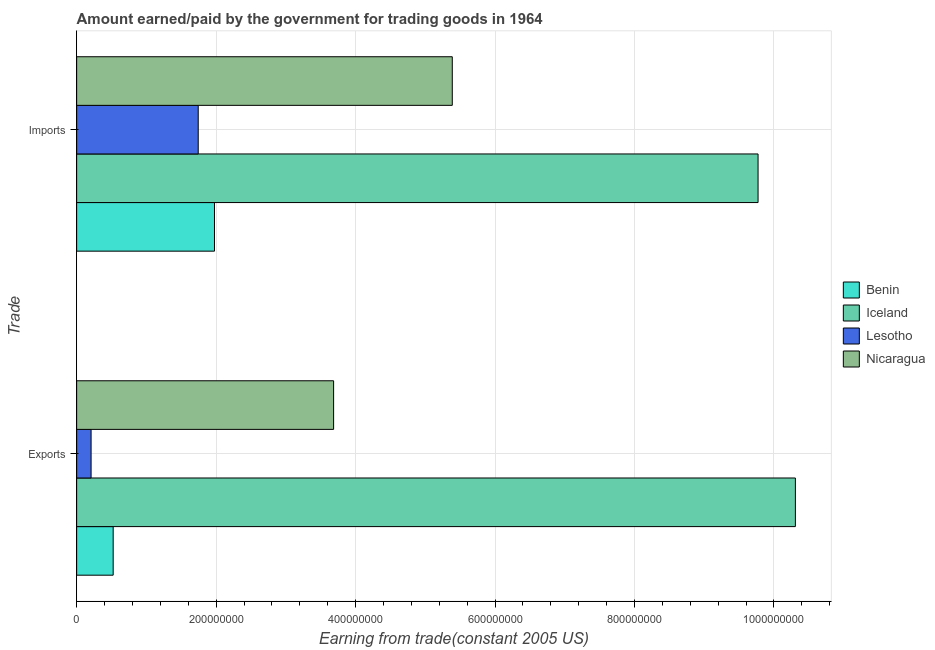How many different coloured bars are there?
Your answer should be very brief. 4. Are the number of bars on each tick of the Y-axis equal?
Give a very brief answer. Yes. How many bars are there on the 2nd tick from the top?
Your answer should be very brief. 4. How many bars are there on the 2nd tick from the bottom?
Ensure brevity in your answer.  4. What is the label of the 2nd group of bars from the top?
Provide a short and direct response. Exports. What is the amount paid for imports in Lesotho?
Offer a terse response. 1.74e+08. Across all countries, what is the maximum amount earned from exports?
Provide a short and direct response. 1.03e+09. Across all countries, what is the minimum amount earned from exports?
Offer a very short reply. 2.07e+07. In which country was the amount earned from exports maximum?
Ensure brevity in your answer.  Iceland. In which country was the amount paid for imports minimum?
Your answer should be compact. Lesotho. What is the total amount earned from exports in the graph?
Your answer should be compact. 1.47e+09. What is the difference between the amount earned from exports in Benin and that in Lesotho?
Make the answer very short. 3.17e+07. What is the difference between the amount paid for imports in Lesotho and the amount earned from exports in Iceland?
Provide a succinct answer. -8.56e+08. What is the average amount paid for imports per country?
Keep it short and to the point. 4.72e+08. What is the difference between the amount paid for imports and amount earned from exports in Iceland?
Offer a very short reply. -5.35e+07. What is the ratio of the amount paid for imports in Iceland to that in Lesotho?
Keep it short and to the point. 5.61. What does the 2nd bar from the top in Imports represents?
Make the answer very short. Lesotho. What does the 3rd bar from the bottom in Imports represents?
Offer a terse response. Lesotho. Are all the bars in the graph horizontal?
Keep it short and to the point. Yes. What is the difference between two consecutive major ticks on the X-axis?
Your response must be concise. 2.00e+08. Does the graph contain any zero values?
Make the answer very short. No. Does the graph contain grids?
Your answer should be very brief. Yes. How are the legend labels stacked?
Your answer should be very brief. Vertical. What is the title of the graph?
Keep it short and to the point. Amount earned/paid by the government for trading goods in 1964. Does "Tuvalu" appear as one of the legend labels in the graph?
Your response must be concise. No. What is the label or title of the X-axis?
Give a very brief answer. Earning from trade(constant 2005 US). What is the label or title of the Y-axis?
Provide a short and direct response. Trade. What is the Earning from trade(constant 2005 US) in Benin in Exports?
Make the answer very short. 5.24e+07. What is the Earning from trade(constant 2005 US) of Iceland in Exports?
Your answer should be very brief. 1.03e+09. What is the Earning from trade(constant 2005 US) of Lesotho in Exports?
Your response must be concise. 2.07e+07. What is the Earning from trade(constant 2005 US) of Nicaragua in Exports?
Offer a very short reply. 3.68e+08. What is the Earning from trade(constant 2005 US) of Benin in Imports?
Keep it short and to the point. 1.98e+08. What is the Earning from trade(constant 2005 US) in Iceland in Imports?
Offer a terse response. 9.77e+08. What is the Earning from trade(constant 2005 US) of Lesotho in Imports?
Your response must be concise. 1.74e+08. What is the Earning from trade(constant 2005 US) of Nicaragua in Imports?
Provide a succinct answer. 5.39e+08. Across all Trade, what is the maximum Earning from trade(constant 2005 US) in Benin?
Your response must be concise. 1.98e+08. Across all Trade, what is the maximum Earning from trade(constant 2005 US) in Iceland?
Provide a short and direct response. 1.03e+09. Across all Trade, what is the maximum Earning from trade(constant 2005 US) of Lesotho?
Your answer should be very brief. 1.74e+08. Across all Trade, what is the maximum Earning from trade(constant 2005 US) in Nicaragua?
Make the answer very short. 5.39e+08. Across all Trade, what is the minimum Earning from trade(constant 2005 US) in Benin?
Ensure brevity in your answer.  5.24e+07. Across all Trade, what is the minimum Earning from trade(constant 2005 US) of Iceland?
Ensure brevity in your answer.  9.77e+08. Across all Trade, what is the minimum Earning from trade(constant 2005 US) of Lesotho?
Your response must be concise. 2.07e+07. Across all Trade, what is the minimum Earning from trade(constant 2005 US) in Nicaragua?
Your answer should be compact. 3.68e+08. What is the total Earning from trade(constant 2005 US) in Benin in the graph?
Offer a terse response. 2.50e+08. What is the total Earning from trade(constant 2005 US) of Iceland in the graph?
Your response must be concise. 2.01e+09. What is the total Earning from trade(constant 2005 US) of Lesotho in the graph?
Provide a succinct answer. 1.95e+08. What is the total Earning from trade(constant 2005 US) in Nicaragua in the graph?
Your response must be concise. 9.07e+08. What is the difference between the Earning from trade(constant 2005 US) of Benin in Exports and that in Imports?
Give a very brief answer. -1.45e+08. What is the difference between the Earning from trade(constant 2005 US) in Iceland in Exports and that in Imports?
Provide a succinct answer. 5.35e+07. What is the difference between the Earning from trade(constant 2005 US) of Lesotho in Exports and that in Imports?
Keep it short and to the point. -1.54e+08. What is the difference between the Earning from trade(constant 2005 US) in Nicaragua in Exports and that in Imports?
Give a very brief answer. -1.70e+08. What is the difference between the Earning from trade(constant 2005 US) of Benin in Exports and the Earning from trade(constant 2005 US) of Iceland in Imports?
Offer a very short reply. -9.25e+08. What is the difference between the Earning from trade(constant 2005 US) in Benin in Exports and the Earning from trade(constant 2005 US) in Lesotho in Imports?
Offer a very short reply. -1.22e+08. What is the difference between the Earning from trade(constant 2005 US) of Benin in Exports and the Earning from trade(constant 2005 US) of Nicaragua in Imports?
Your answer should be very brief. -4.86e+08. What is the difference between the Earning from trade(constant 2005 US) in Iceland in Exports and the Earning from trade(constant 2005 US) in Lesotho in Imports?
Keep it short and to the point. 8.56e+08. What is the difference between the Earning from trade(constant 2005 US) of Iceland in Exports and the Earning from trade(constant 2005 US) of Nicaragua in Imports?
Offer a terse response. 4.92e+08. What is the difference between the Earning from trade(constant 2005 US) in Lesotho in Exports and the Earning from trade(constant 2005 US) in Nicaragua in Imports?
Ensure brevity in your answer.  -5.18e+08. What is the average Earning from trade(constant 2005 US) in Benin per Trade?
Give a very brief answer. 1.25e+08. What is the average Earning from trade(constant 2005 US) of Iceland per Trade?
Your answer should be compact. 1.00e+09. What is the average Earning from trade(constant 2005 US) in Lesotho per Trade?
Keep it short and to the point. 9.75e+07. What is the average Earning from trade(constant 2005 US) in Nicaragua per Trade?
Give a very brief answer. 4.54e+08. What is the difference between the Earning from trade(constant 2005 US) of Benin and Earning from trade(constant 2005 US) of Iceland in Exports?
Your response must be concise. -9.78e+08. What is the difference between the Earning from trade(constant 2005 US) in Benin and Earning from trade(constant 2005 US) in Lesotho in Exports?
Give a very brief answer. 3.17e+07. What is the difference between the Earning from trade(constant 2005 US) in Benin and Earning from trade(constant 2005 US) in Nicaragua in Exports?
Keep it short and to the point. -3.16e+08. What is the difference between the Earning from trade(constant 2005 US) in Iceland and Earning from trade(constant 2005 US) in Lesotho in Exports?
Give a very brief answer. 1.01e+09. What is the difference between the Earning from trade(constant 2005 US) of Iceland and Earning from trade(constant 2005 US) of Nicaragua in Exports?
Give a very brief answer. 6.62e+08. What is the difference between the Earning from trade(constant 2005 US) of Lesotho and Earning from trade(constant 2005 US) of Nicaragua in Exports?
Your answer should be very brief. -3.48e+08. What is the difference between the Earning from trade(constant 2005 US) of Benin and Earning from trade(constant 2005 US) of Iceland in Imports?
Offer a terse response. -7.80e+08. What is the difference between the Earning from trade(constant 2005 US) of Benin and Earning from trade(constant 2005 US) of Lesotho in Imports?
Keep it short and to the point. 2.33e+07. What is the difference between the Earning from trade(constant 2005 US) in Benin and Earning from trade(constant 2005 US) in Nicaragua in Imports?
Your answer should be very brief. -3.41e+08. What is the difference between the Earning from trade(constant 2005 US) in Iceland and Earning from trade(constant 2005 US) in Lesotho in Imports?
Provide a succinct answer. 8.03e+08. What is the difference between the Earning from trade(constant 2005 US) of Iceland and Earning from trade(constant 2005 US) of Nicaragua in Imports?
Provide a succinct answer. 4.39e+08. What is the difference between the Earning from trade(constant 2005 US) of Lesotho and Earning from trade(constant 2005 US) of Nicaragua in Imports?
Ensure brevity in your answer.  -3.64e+08. What is the ratio of the Earning from trade(constant 2005 US) of Benin in Exports to that in Imports?
Your answer should be very brief. 0.27. What is the ratio of the Earning from trade(constant 2005 US) of Iceland in Exports to that in Imports?
Your response must be concise. 1.05. What is the ratio of the Earning from trade(constant 2005 US) in Lesotho in Exports to that in Imports?
Provide a succinct answer. 0.12. What is the ratio of the Earning from trade(constant 2005 US) in Nicaragua in Exports to that in Imports?
Offer a terse response. 0.68. What is the difference between the highest and the second highest Earning from trade(constant 2005 US) of Benin?
Give a very brief answer. 1.45e+08. What is the difference between the highest and the second highest Earning from trade(constant 2005 US) in Iceland?
Your answer should be very brief. 5.35e+07. What is the difference between the highest and the second highest Earning from trade(constant 2005 US) of Lesotho?
Keep it short and to the point. 1.54e+08. What is the difference between the highest and the second highest Earning from trade(constant 2005 US) in Nicaragua?
Your answer should be compact. 1.70e+08. What is the difference between the highest and the lowest Earning from trade(constant 2005 US) of Benin?
Keep it short and to the point. 1.45e+08. What is the difference between the highest and the lowest Earning from trade(constant 2005 US) of Iceland?
Offer a terse response. 5.35e+07. What is the difference between the highest and the lowest Earning from trade(constant 2005 US) in Lesotho?
Your answer should be compact. 1.54e+08. What is the difference between the highest and the lowest Earning from trade(constant 2005 US) of Nicaragua?
Offer a terse response. 1.70e+08. 